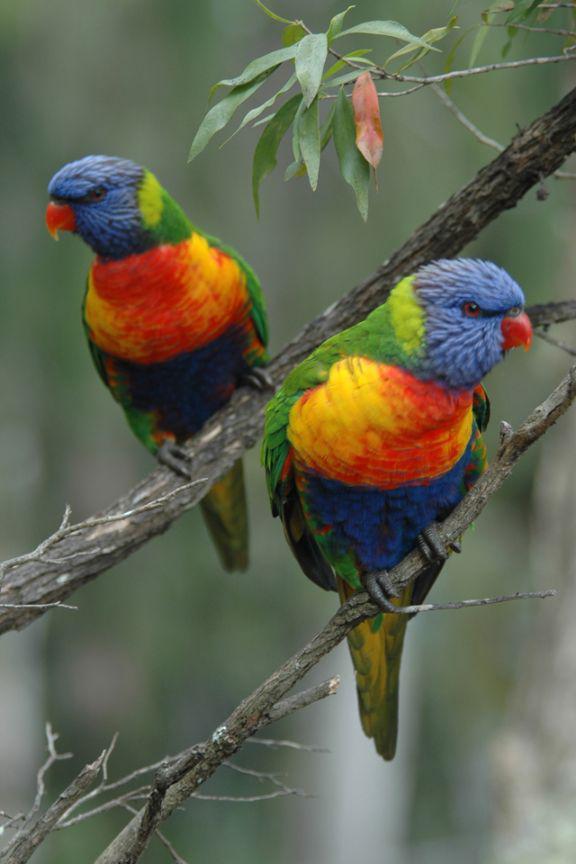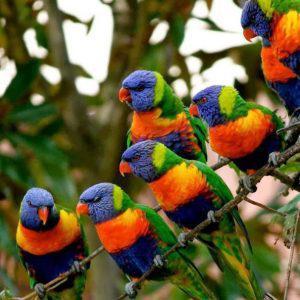The first image is the image on the left, the second image is the image on the right. Considering the images on both sides, is "There is no more than two parrots." valid? Answer yes or no. No. 